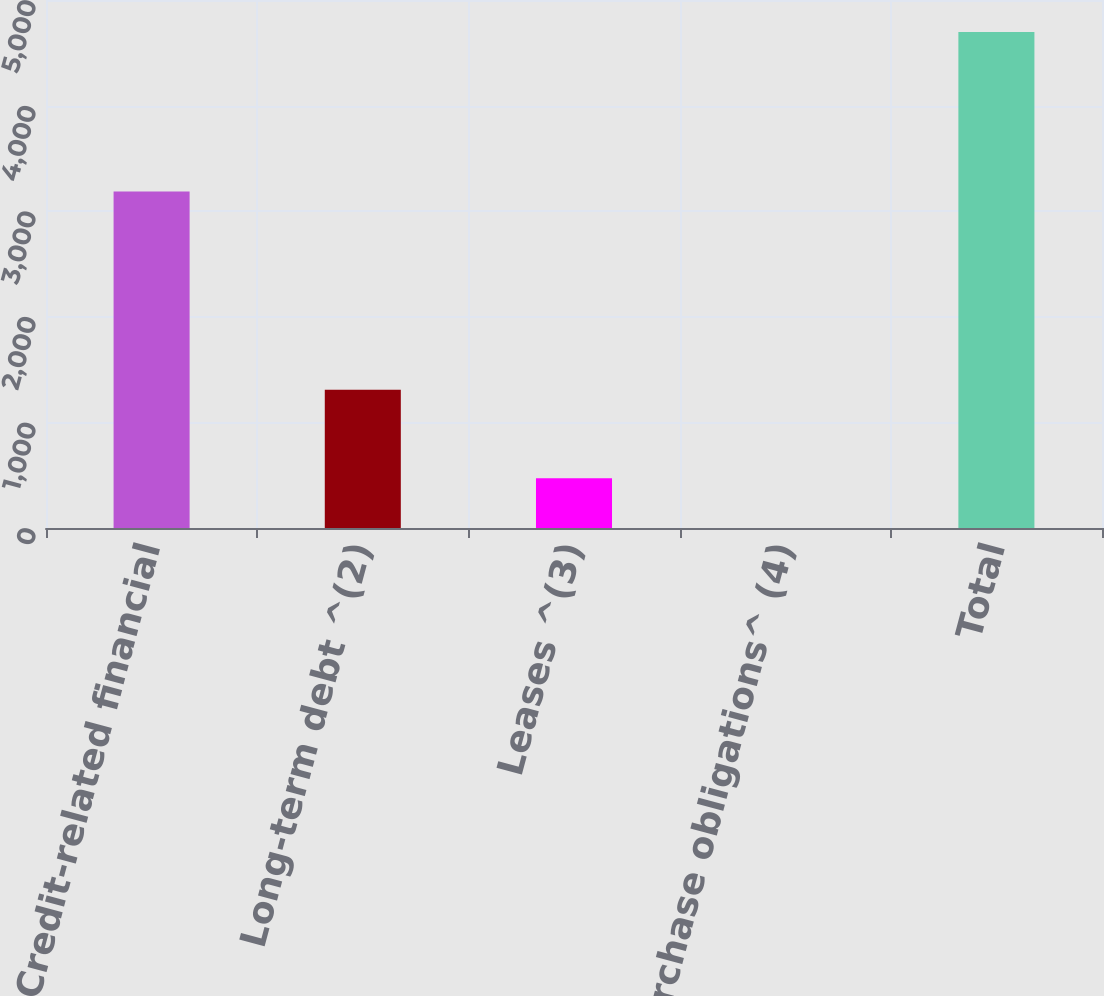Convert chart. <chart><loc_0><loc_0><loc_500><loc_500><bar_chart><fcel>Credit-related financial<fcel>Long-term debt ^(2)<fcel>Leases ^(3)<fcel>Purchase obligations^ (4)<fcel>Total<nl><fcel>3186<fcel>1309<fcel>470.6<fcel>1<fcel>4697<nl></chart> 